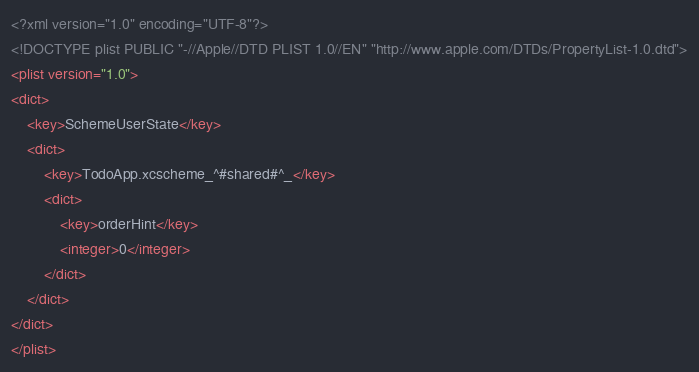Convert code to text. <code><loc_0><loc_0><loc_500><loc_500><_XML_><?xml version="1.0" encoding="UTF-8"?>
<!DOCTYPE plist PUBLIC "-//Apple//DTD PLIST 1.0//EN" "http://www.apple.com/DTDs/PropertyList-1.0.dtd">
<plist version="1.0">
<dict>
	<key>SchemeUserState</key>
	<dict>
		<key>TodoApp.xcscheme_^#shared#^_</key>
		<dict>
			<key>orderHint</key>
			<integer>0</integer>
		</dict>
	</dict>
</dict>
</plist>
</code> 